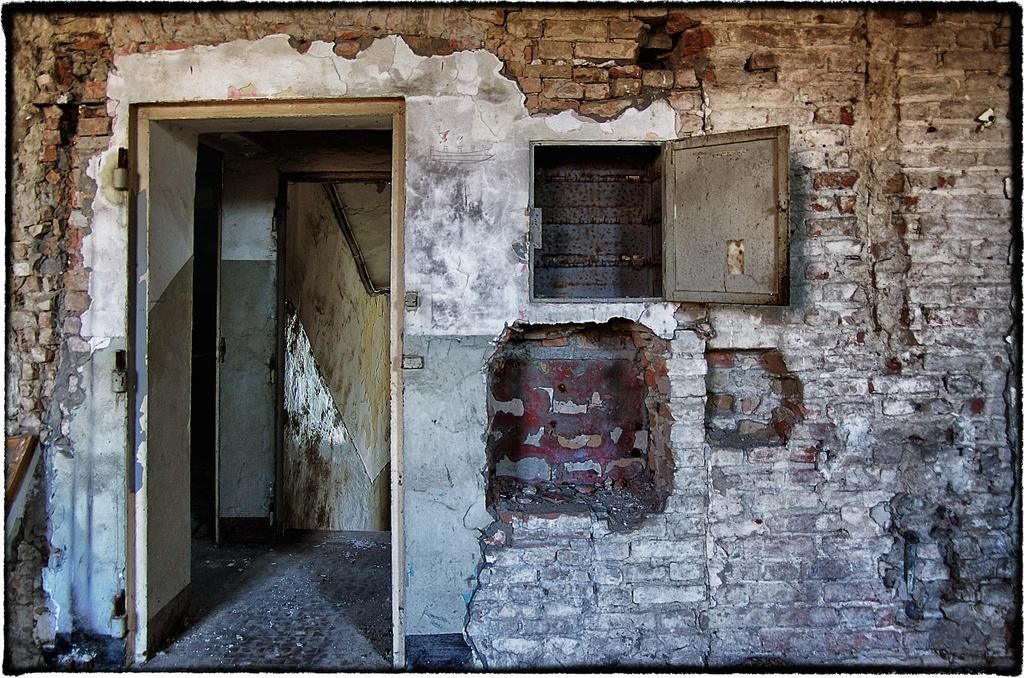What is the main subject of the image? The main subject of the image is a destroyed building. What features can be seen on the building? The building has doors. What additional object is present in the image? There is a box attached to the wall in the image. What type of pin can be seen holding the railway system together in the image? There is no railway system or pin present in the image; it features a destroyed building and a box attached to the wall. 